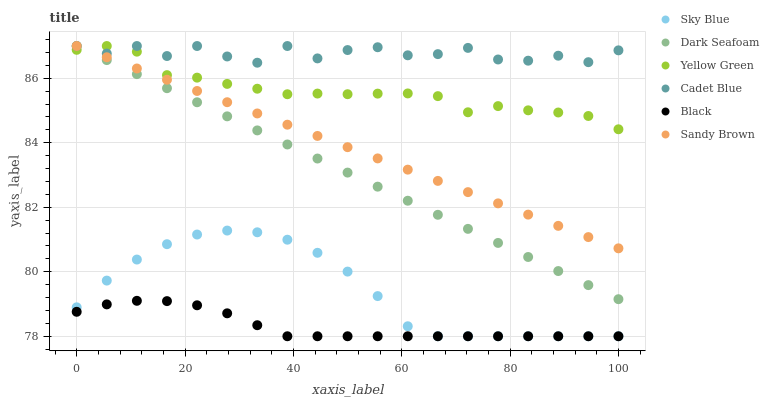Does Black have the minimum area under the curve?
Answer yes or no. Yes. Does Cadet Blue have the maximum area under the curve?
Answer yes or no. Yes. Does Yellow Green have the minimum area under the curve?
Answer yes or no. No. Does Yellow Green have the maximum area under the curve?
Answer yes or no. No. Is Dark Seafoam the smoothest?
Answer yes or no. Yes. Is Cadet Blue the roughest?
Answer yes or no. Yes. Is Yellow Green the smoothest?
Answer yes or no. No. Is Yellow Green the roughest?
Answer yes or no. No. Does Black have the lowest value?
Answer yes or no. Yes. Does Yellow Green have the lowest value?
Answer yes or no. No. Does Sandy Brown have the highest value?
Answer yes or no. Yes. Does Black have the highest value?
Answer yes or no. No. Is Sky Blue less than Sandy Brown?
Answer yes or no. Yes. Is Cadet Blue greater than Sky Blue?
Answer yes or no. Yes. Does Dark Seafoam intersect Sandy Brown?
Answer yes or no. Yes. Is Dark Seafoam less than Sandy Brown?
Answer yes or no. No. Is Dark Seafoam greater than Sandy Brown?
Answer yes or no. No. Does Sky Blue intersect Sandy Brown?
Answer yes or no. No. 